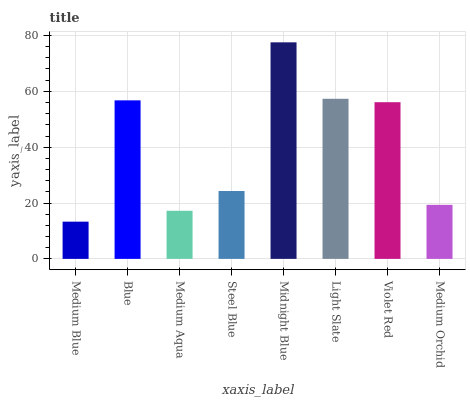Is Blue the minimum?
Answer yes or no. No. Is Blue the maximum?
Answer yes or no. No. Is Blue greater than Medium Blue?
Answer yes or no. Yes. Is Medium Blue less than Blue?
Answer yes or no. Yes. Is Medium Blue greater than Blue?
Answer yes or no. No. Is Blue less than Medium Blue?
Answer yes or no. No. Is Violet Red the high median?
Answer yes or no. Yes. Is Steel Blue the low median?
Answer yes or no. Yes. Is Steel Blue the high median?
Answer yes or no. No. Is Medium Aqua the low median?
Answer yes or no. No. 